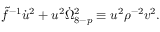Convert formula to latex. <formula><loc_0><loc_0><loc_500><loc_500>\tilde { f } ^ { - 1 } \dot { u } ^ { 2 } + u ^ { 2 } \dot { \Omega } _ { 8 - p } ^ { 2 } \equiv u ^ { 2 } { \rho } ^ { - 2 } v ^ { 2 } .</formula> 